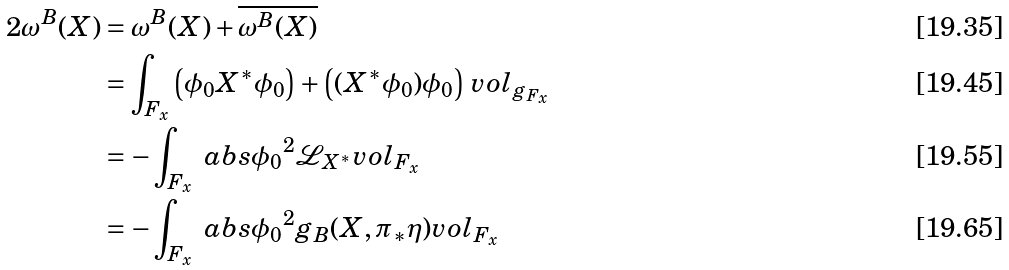<formula> <loc_0><loc_0><loc_500><loc_500>2 \omega ^ { B } ( X ) & = \omega ^ { B } ( X ) + \overline { \omega ^ { B } ( X ) } \\ & = \int _ { F _ { x } } \left ( \phi _ { 0 } X ^ { * } \phi _ { 0 } \right ) + \left ( ( X ^ { * } \phi _ { 0 } ) \phi _ { 0 } \right ) \, v o l _ { g _ { F _ { x } } } \\ & = - \int _ { F _ { x } } \ a b s { \phi _ { 0 } } ^ { 2 } \mathcal { L } _ { X ^ { * } } v o l _ { F _ { x } } \\ & = - \int _ { F _ { x } } \ a b s { \phi _ { 0 } } ^ { 2 } g _ { B } ( X , \pi _ { * } \eta ) v o l _ { F _ { x } }</formula> 